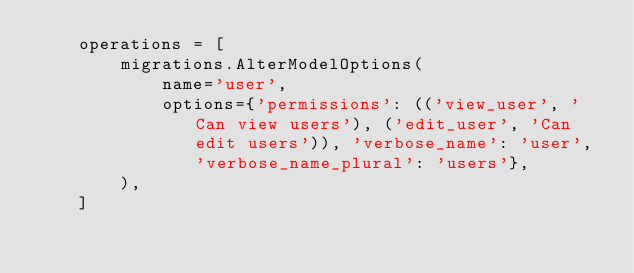<code> <loc_0><loc_0><loc_500><loc_500><_Python_>    operations = [
        migrations.AlterModelOptions(
            name='user',
            options={'permissions': (('view_user', 'Can view users'), ('edit_user', 'Can edit users')), 'verbose_name': 'user', 'verbose_name_plural': 'users'},
        ),
    ]
</code> 